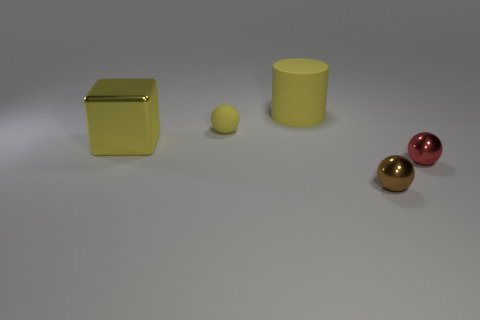Does the small object that is behind the large yellow metal thing have the same shape as the big thing that is behind the cube?
Provide a short and direct response. No. The big thing that is behind the small object on the left side of the rubber cylinder is what shape?
Ensure brevity in your answer.  Cylinder. The rubber ball that is the same color as the big rubber thing is what size?
Make the answer very short. Small. Are there any yellow objects that have the same material as the large yellow cube?
Make the answer very short. No. There is a tiny ball that is left of the tiny brown shiny ball; what material is it?
Keep it short and to the point. Rubber. What material is the tiny yellow sphere?
Provide a short and direct response. Rubber. Are the large yellow thing in front of the yellow cylinder and the tiny brown object made of the same material?
Your answer should be compact. Yes. Is the number of spheres to the left of the large cylinder less than the number of spheres?
Your response must be concise. Yes. There is a metal ball that is the same size as the red thing; what is its color?
Make the answer very short. Brown. What number of other objects have the same shape as the big yellow metal object?
Provide a succinct answer. 0. 